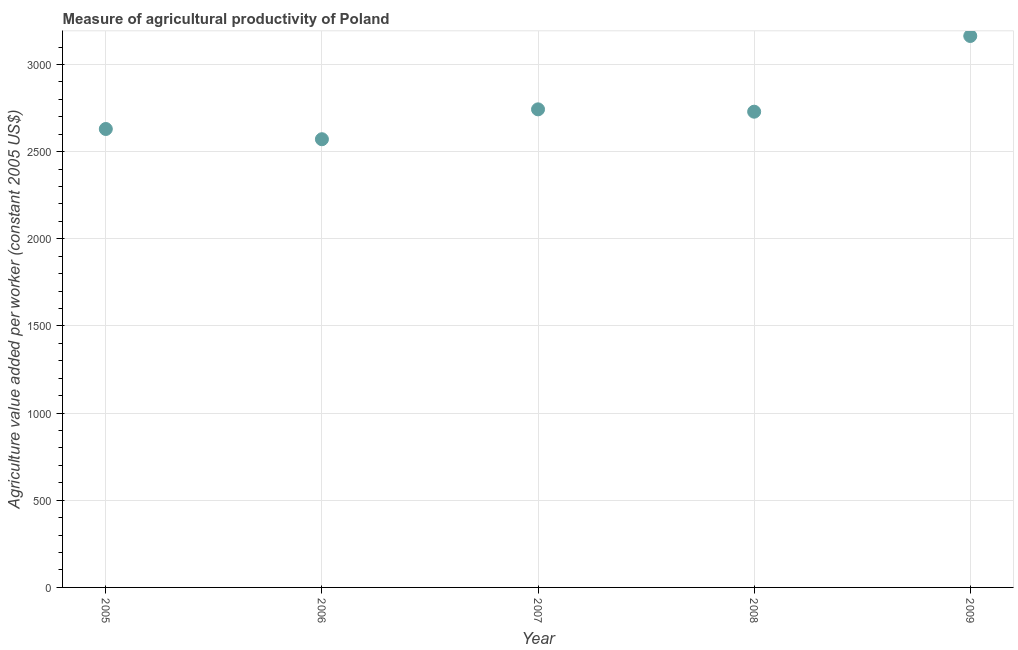What is the agriculture value added per worker in 2009?
Offer a terse response. 3163.61. Across all years, what is the maximum agriculture value added per worker?
Keep it short and to the point. 3163.61. Across all years, what is the minimum agriculture value added per worker?
Provide a short and direct response. 2571.35. In which year was the agriculture value added per worker maximum?
Your response must be concise. 2009. What is the sum of the agriculture value added per worker?
Provide a succinct answer. 1.38e+04. What is the difference between the agriculture value added per worker in 2007 and 2009?
Your response must be concise. -420.85. What is the average agriculture value added per worker per year?
Provide a short and direct response. 2767.41. What is the median agriculture value added per worker?
Provide a short and direct response. 2729.29. Do a majority of the years between 2006 and 2008 (inclusive) have agriculture value added per worker greater than 1700 US$?
Offer a terse response. Yes. What is the ratio of the agriculture value added per worker in 2006 to that in 2008?
Your response must be concise. 0.94. Is the agriculture value added per worker in 2006 less than that in 2008?
Give a very brief answer. Yes. Is the difference between the agriculture value added per worker in 2005 and 2006 greater than the difference between any two years?
Your response must be concise. No. What is the difference between the highest and the second highest agriculture value added per worker?
Offer a very short reply. 420.85. Is the sum of the agriculture value added per worker in 2005 and 2008 greater than the maximum agriculture value added per worker across all years?
Your answer should be compact. Yes. What is the difference between the highest and the lowest agriculture value added per worker?
Your answer should be compact. 592.26. In how many years, is the agriculture value added per worker greater than the average agriculture value added per worker taken over all years?
Ensure brevity in your answer.  1. Does the agriculture value added per worker monotonically increase over the years?
Provide a short and direct response. No. How many dotlines are there?
Your response must be concise. 1. What is the difference between two consecutive major ticks on the Y-axis?
Offer a terse response. 500. Does the graph contain grids?
Your response must be concise. Yes. What is the title of the graph?
Offer a very short reply. Measure of agricultural productivity of Poland. What is the label or title of the X-axis?
Your response must be concise. Year. What is the label or title of the Y-axis?
Offer a terse response. Agriculture value added per worker (constant 2005 US$). What is the Agriculture value added per worker (constant 2005 US$) in 2005?
Provide a short and direct response. 2630.05. What is the Agriculture value added per worker (constant 2005 US$) in 2006?
Provide a short and direct response. 2571.35. What is the Agriculture value added per worker (constant 2005 US$) in 2007?
Your response must be concise. 2742.76. What is the Agriculture value added per worker (constant 2005 US$) in 2008?
Keep it short and to the point. 2729.29. What is the Agriculture value added per worker (constant 2005 US$) in 2009?
Your answer should be very brief. 3163.61. What is the difference between the Agriculture value added per worker (constant 2005 US$) in 2005 and 2006?
Make the answer very short. 58.7. What is the difference between the Agriculture value added per worker (constant 2005 US$) in 2005 and 2007?
Your answer should be very brief. -112.71. What is the difference between the Agriculture value added per worker (constant 2005 US$) in 2005 and 2008?
Provide a succinct answer. -99.25. What is the difference between the Agriculture value added per worker (constant 2005 US$) in 2005 and 2009?
Keep it short and to the point. -533.56. What is the difference between the Agriculture value added per worker (constant 2005 US$) in 2006 and 2007?
Your answer should be compact. -171.41. What is the difference between the Agriculture value added per worker (constant 2005 US$) in 2006 and 2008?
Make the answer very short. -157.95. What is the difference between the Agriculture value added per worker (constant 2005 US$) in 2006 and 2009?
Your response must be concise. -592.26. What is the difference between the Agriculture value added per worker (constant 2005 US$) in 2007 and 2008?
Provide a succinct answer. 13.46. What is the difference between the Agriculture value added per worker (constant 2005 US$) in 2007 and 2009?
Offer a terse response. -420.85. What is the difference between the Agriculture value added per worker (constant 2005 US$) in 2008 and 2009?
Ensure brevity in your answer.  -434.31. What is the ratio of the Agriculture value added per worker (constant 2005 US$) in 2005 to that in 2006?
Provide a succinct answer. 1.02. What is the ratio of the Agriculture value added per worker (constant 2005 US$) in 2005 to that in 2007?
Your response must be concise. 0.96. What is the ratio of the Agriculture value added per worker (constant 2005 US$) in 2005 to that in 2008?
Offer a very short reply. 0.96. What is the ratio of the Agriculture value added per worker (constant 2005 US$) in 2005 to that in 2009?
Give a very brief answer. 0.83. What is the ratio of the Agriculture value added per worker (constant 2005 US$) in 2006 to that in 2007?
Your response must be concise. 0.94. What is the ratio of the Agriculture value added per worker (constant 2005 US$) in 2006 to that in 2008?
Provide a short and direct response. 0.94. What is the ratio of the Agriculture value added per worker (constant 2005 US$) in 2006 to that in 2009?
Give a very brief answer. 0.81. What is the ratio of the Agriculture value added per worker (constant 2005 US$) in 2007 to that in 2008?
Provide a short and direct response. 1. What is the ratio of the Agriculture value added per worker (constant 2005 US$) in 2007 to that in 2009?
Make the answer very short. 0.87. What is the ratio of the Agriculture value added per worker (constant 2005 US$) in 2008 to that in 2009?
Keep it short and to the point. 0.86. 